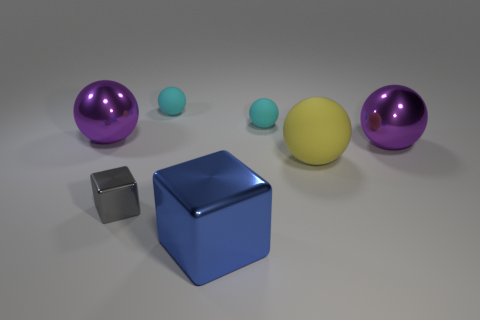How many other objects are the same material as the big yellow sphere?
Keep it short and to the point. 2. How many shiny objects are both behind the small gray thing and right of the tiny gray metallic thing?
Provide a succinct answer. 1. What color is the tiny cube?
Provide a succinct answer. Gray. What is the material of the other thing that is the same shape as the tiny shiny object?
Make the answer very short. Metal. Is the big matte thing the same color as the small metallic cube?
Your answer should be compact. No. What is the shape of the cyan thing that is behind the small cyan sphere that is right of the blue cube?
Offer a very short reply. Sphere. The large blue object that is the same material as the small gray block is what shape?
Your answer should be compact. Cube. How many other objects are the same shape as the big blue shiny thing?
Give a very brief answer. 1. There is a purple metallic ball to the left of the blue block; does it have the same size as the big rubber object?
Your response must be concise. Yes. Are there more blue things behind the small gray block than large green matte cylinders?
Provide a short and direct response. No. 